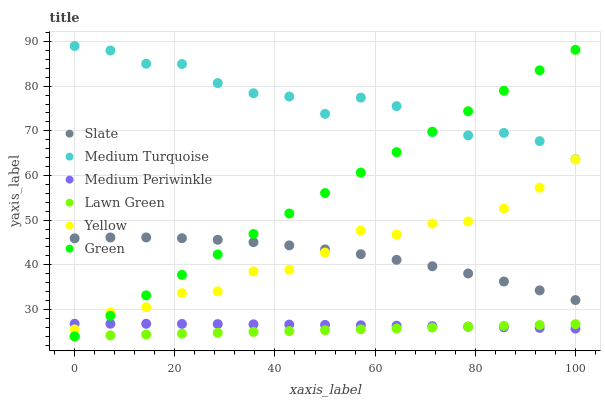Does Lawn Green have the minimum area under the curve?
Answer yes or no. Yes. Does Medium Turquoise have the maximum area under the curve?
Answer yes or no. Yes. Does Slate have the minimum area under the curve?
Answer yes or no. No. Does Slate have the maximum area under the curve?
Answer yes or no. No. Is Lawn Green the smoothest?
Answer yes or no. Yes. Is Medium Turquoise the roughest?
Answer yes or no. Yes. Is Slate the smoothest?
Answer yes or no. No. Is Slate the roughest?
Answer yes or no. No. Does Lawn Green have the lowest value?
Answer yes or no. Yes. Does Slate have the lowest value?
Answer yes or no. No. Does Medium Turquoise have the highest value?
Answer yes or no. Yes. Does Slate have the highest value?
Answer yes or no. No. Is Medium Periwinkle less than Medium Turquoise?
Answer yes or no. Yes. Is Medium Turquoise greater than Yellow?
Answer yes or no. Yes. Does Medium Periwinkle intersect Lawn Green?
Answer yes or no. Yes. Is Medium Periwinkle less than Lawn Green?
Answer yes or no. No. Is Medium Periwinkle greater than Lawn Green?
Answer yes or no. No. Does Medium Periwinkle intersect Medium Turquoise?
Answer yes or no. No. 